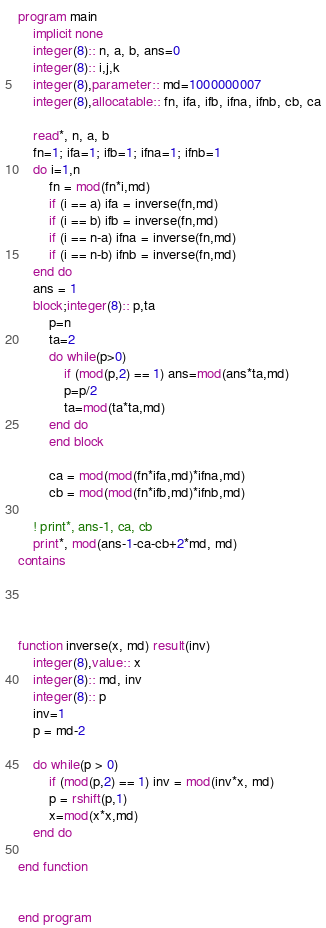<code> <loc_0><loc_0><loc_500><loc_500><_FORTRAN_>program main
    implicit none
    integer(8):: n, a, b, ans=0
    integer(8):: i,j,k
    integer(8),parameter:: md=1000000007
    integer(8),allocatable:: fn, ifa, ifb, ifna, ifnb, cb, ca

    read*, n, a, b
    fn=1; ifa=1; ifb=1; ifna=1; ifnb=1
    do i=1,n
        fn = mod(fn*i,md)
        if (i == a) ifa = inverse(fn,md)
        if (i == b) ifb = inverse(fn,md)
        if (i == n-a) ifna = inverse(fn,md)
        if (i == n-b) ifnb = inverse(fn,md)
    end do
    ans = 1
    block;integer(8):: p,ta
        p=n
        ta=2
        do while(p>0)
            if (mod(p,2) == 1) ans=mod(ans*ta,md)
            p=p/2
            ta=mod(ta*ta,md)
        end do
        end block

        ca = mod(mod(fn*ifa,md)*ifna,md)
        cb = mod(mod(fn*ifb,md)*ifnb,md)

    ! print*, ans-1, ca, cb
    print*, mod(ans-1-ca-cb+2*md, md)
contains




function inverse(x, md) result(inv)
    integer(8),value:: x
    integer(8):: md, inv
    integer(8):: p
    inv=1
    p = md-2

    do while(p > 0)
        if (mod(p,2) == 1) inv = mod(inv*x, md)
        p = rshift(p,1)
        x=mod(x*x,md)
    end do
    
end function


end program
</code> 